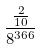<formula> <loc_0><loc_0><loc_500><loc_500>\frac { \frac { 2 } { 1 0 } } { 8 ^ { 3 6 6 } }</formula> 